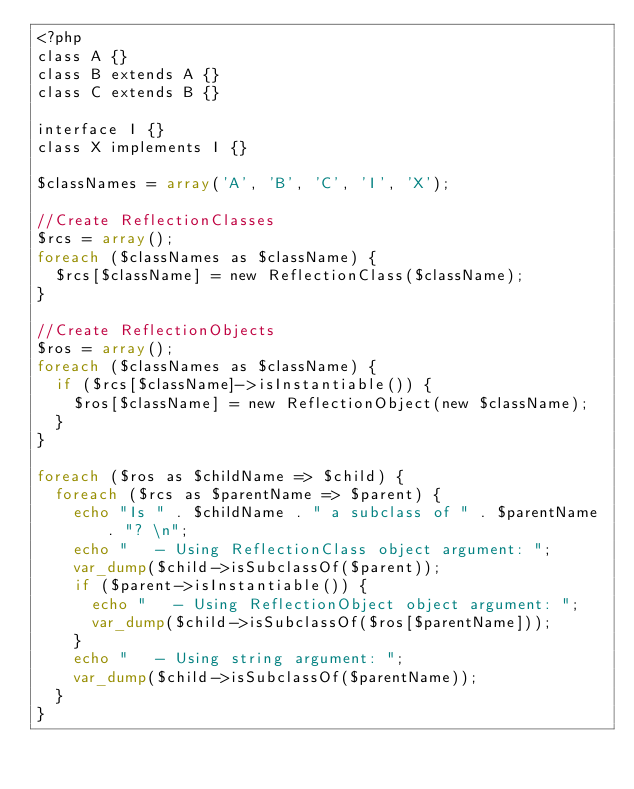Convert code to text. <code><loc_0><loc_0><loc_500><loc_500><_PHP_><?php
class A {}
class B extends A {}
class C extends B {}

interface I {}
class X implements I {}

$classNames = array('A', 'B', 'C', 'I', 'X');

//Create ReflectionClasses
$rcs = array();
foreach ($classNames as $className) {
	$rcs[$className] = new ReflectionClass($className);
}

//Create ReflectionObjects
$ros = array();
foreach ($classNames as $className) {
	if ($rcs[$className]->isInstantiable()) {
		$ros[$className] = new ReflectionObject(new $className);
	}
}

foreach ($ros as $childName => $child) {
	foreach ($rcs as $parentName => $parent) {
		echo "Is " . $childName . " a subclass of " . $parentName . "? \n";
		echo "   - Using ReflectionClass object argument: ";
		var_dump($child->isSubclassOf($parent));
		if ($parent->isInstantiable()) {
			echo "   - Using ReflectionObject object argument: ";
			var_dump($child->isSubclassOf($ros[$parentName]));
		}
		echo "   - Using string argument: ";
		var_dump($child->isSubclassOf($parentName));
	}
}
</code> 